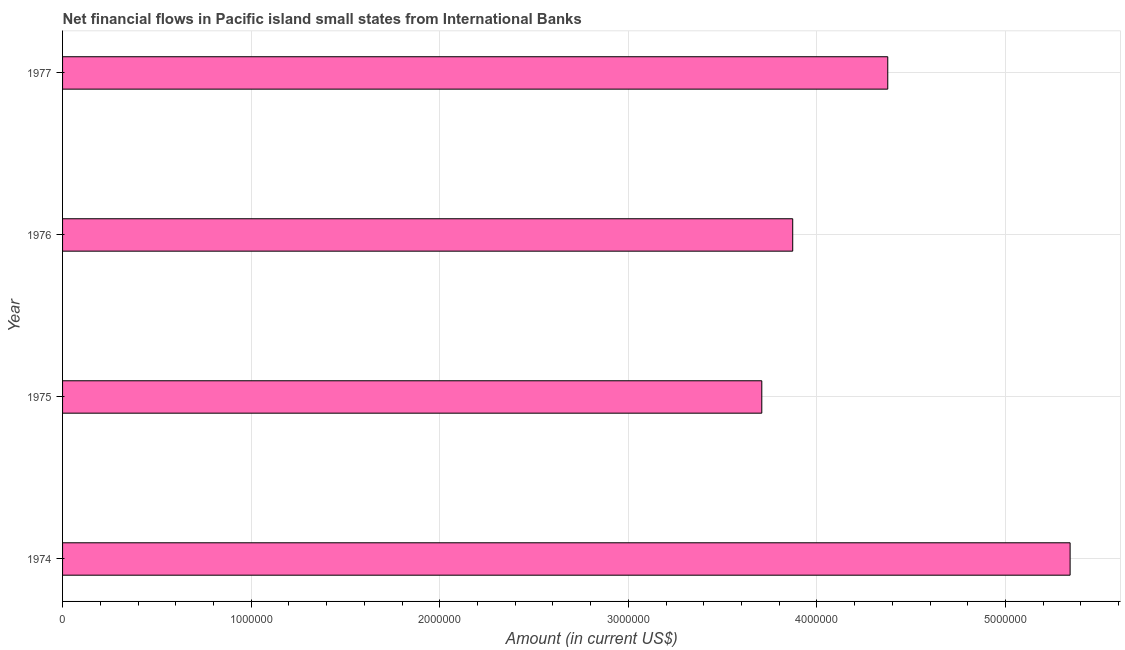Does the graph contain any zero values?
Offer a terse response. No. What is the title of the graph?
Your answer should be very brief. Net financial flows in Pacific island small states from International Banks. What is the net financial flows from ibrd in 1974?
Offer a very short reply. 5.34e+06. Across all years, what is the maximum net financial flows from ibrd?
Provide a short and direct response. 5.34e+06. Across all years, what is the minimum net financial flows from ibrd?
Offer a terse response. 3.71e+06. In which year was the net financial flows from ibrd maximum?
Your response must be concise. 1974. In which year was the net financial flows from ibrd minimum?
Give a very brief answer. 1975. What is the sum of the net financial flows from ibrd?
Provide a succinct answer. 1.73e+07. What is the difference between the net financial flows from ibrd in 1974 and 1977?
Offer a terse response. 9.67e+05. What is the average net financial flows from ibrd per year?
Ensure brevity in your answer.  4.32e+06. What is the median net financial flows from ibrd?
Offer a very short reply. 4.12e+06. What is the ratio of the net financial flows from ibrd in 1974 to that in 1975?
Give a very brief answer. 1.44. Is the net financial flows from ibrd in 1974 less than that in 1975?
Provide a succinct answer. No. Is the difference between the net financial flows from ibrd in 1976 and 1977 greater than the difference between any two years?
Give a very brief answer. No. What is the difference between the highest and the second highest net financial flows from ibrd?
Offer a very short reply. 9.67e+05. Is the sum of the net financial flows from ibrd in 1976 and 1977 greater than the maximum net financial flows from ibrd across all years?
Your response must be concise. Yes. What is the difference between the highest and the lowest net financial flows from ibrd?
Make the answer very short. 1.64e+06. In how many years, is the net financial flows from ibrd greater than the average net financial flows from ibrd taken over all years?
Your answer should be very brief. 2. How many bars are there?
Make the answer very short. 4. Are all the bars in the graph horizontal?
Make the answer very short. Yes. How many years are there in the graph?
Offer a terse response. 4. What is the difference between two consecutive major ticks on the X-axis?
Keep it short and to the point. 1.00e+06. What is the Amount (in current US$) in 1974?
Your response must be concise. 5.34e+06. What is the Amount (in current US$) of 1975?
Your response must be concise. 3.71e+06. What is the Amount (in current US$) of 1976?
Provide a succinct answer. 3.87e+06. What is the Amount (in current US$) in 1977?
Give a very brief answer. 4.38e+06. What is the difference between the Amount (in current US$) in 1974 and 1975?
Give a very brief answer. 1.64e+06. What is the difference between the Amount (in current US$) in 1974 and 1976?
Provide a short and direct response. 1.47e+06. What is the difference between the Amount (in current US$) in 1974 and 1977?
Ensure brevity in your answer.  9.67e+05. What is the difference between the Amount (in current US$) in 1975 and 1976?
Make the answer very short. -1.64e+05. What is the difference between the Amount (in current US$) in 1975 and 1977?
Offer a very short reply. -6.68e+05. What is the difference between the Amount (in current US$) in 1976 and 1977?
Make the answer very short. -5.04e+05. What is the ratio of the Amount (in current US$) in 1974 to that in 1975?
Keep it short and to the point. 1.44. What is the ratio of the Amount (in current US$) in 1974 to that in 1976?
Provide a succinct answer. 1.38. What is the ratio of the Amount (in current US$) in 1974 to that in 1977?
Offer a very short reply. 1.22. What is the ratio of the Amount (in current US$) in 1975 to that in 1976?
Your response must be concise. 0.96. What is the ratio of the Amount (in current US$) in 1975 to that in 1977?
Offer a terse response. 0.85. What is the ratio of the Amount (in current US$) in 1976 to that in 1977?
Provide a short and direct response. 0.89. 